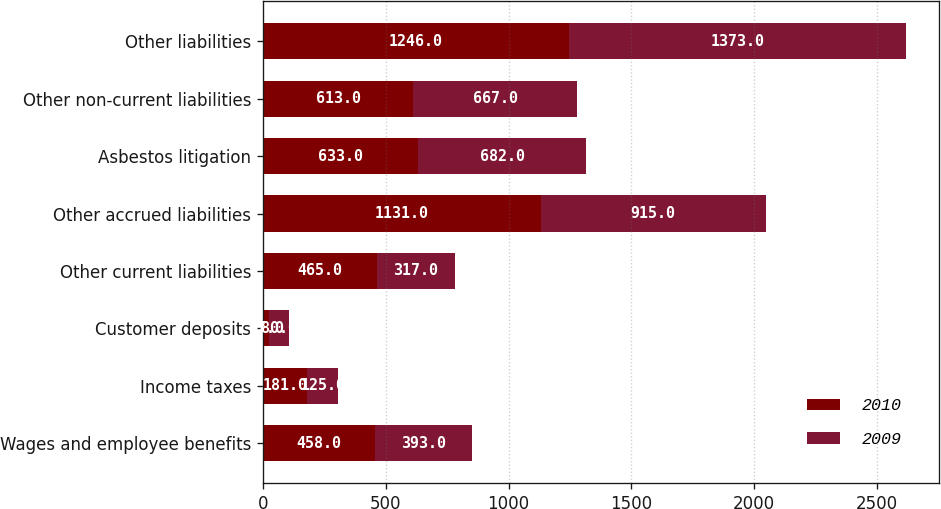Convert chart to OTSL. <chart><loc_0><loc_0><loc_500><loc_500><stacked_bar_chart><ecel><fcel>Wages and employee benefits<fcel>Income taxes<fcel>Customer deposits<fcel>Other current liabilities<fcel>Other accrued liabilities<fcel>Asbestos litigation<fcel>Other non-current liabilities<fcel>Other liabilities<nl><fcel>2010<fcel>458<fcel>181<fcel>27<fcel>465<fcel>1131<fcel>633<fcel>613<fcel>1246<nl><fcel>2009<fcel>393<fcel>125<fcel>80<fcel>317<fcel>915<fcel>682<fcel>667<fcel>1373<nl></chart> 